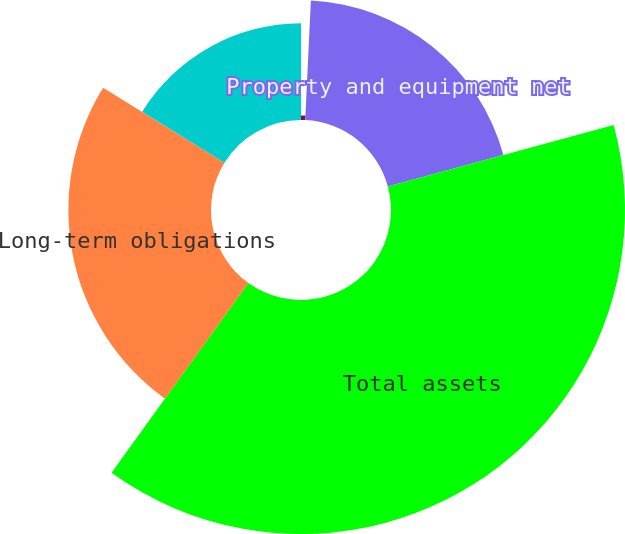Convert chart. <chart><loc_0><loc_0><loc_500><loc_500><pie_chart><fcel>Cash and cash equivalents<fcel>Property and equipment net<fcel>Total assets<fcel>Long-term obligations<fcel>Total stockholders' equity<nl><fcel>0.75%<fcel>20.03%<fcel>39.16%<fcel>23.87%<fcel>16.19%<nl></chart> 